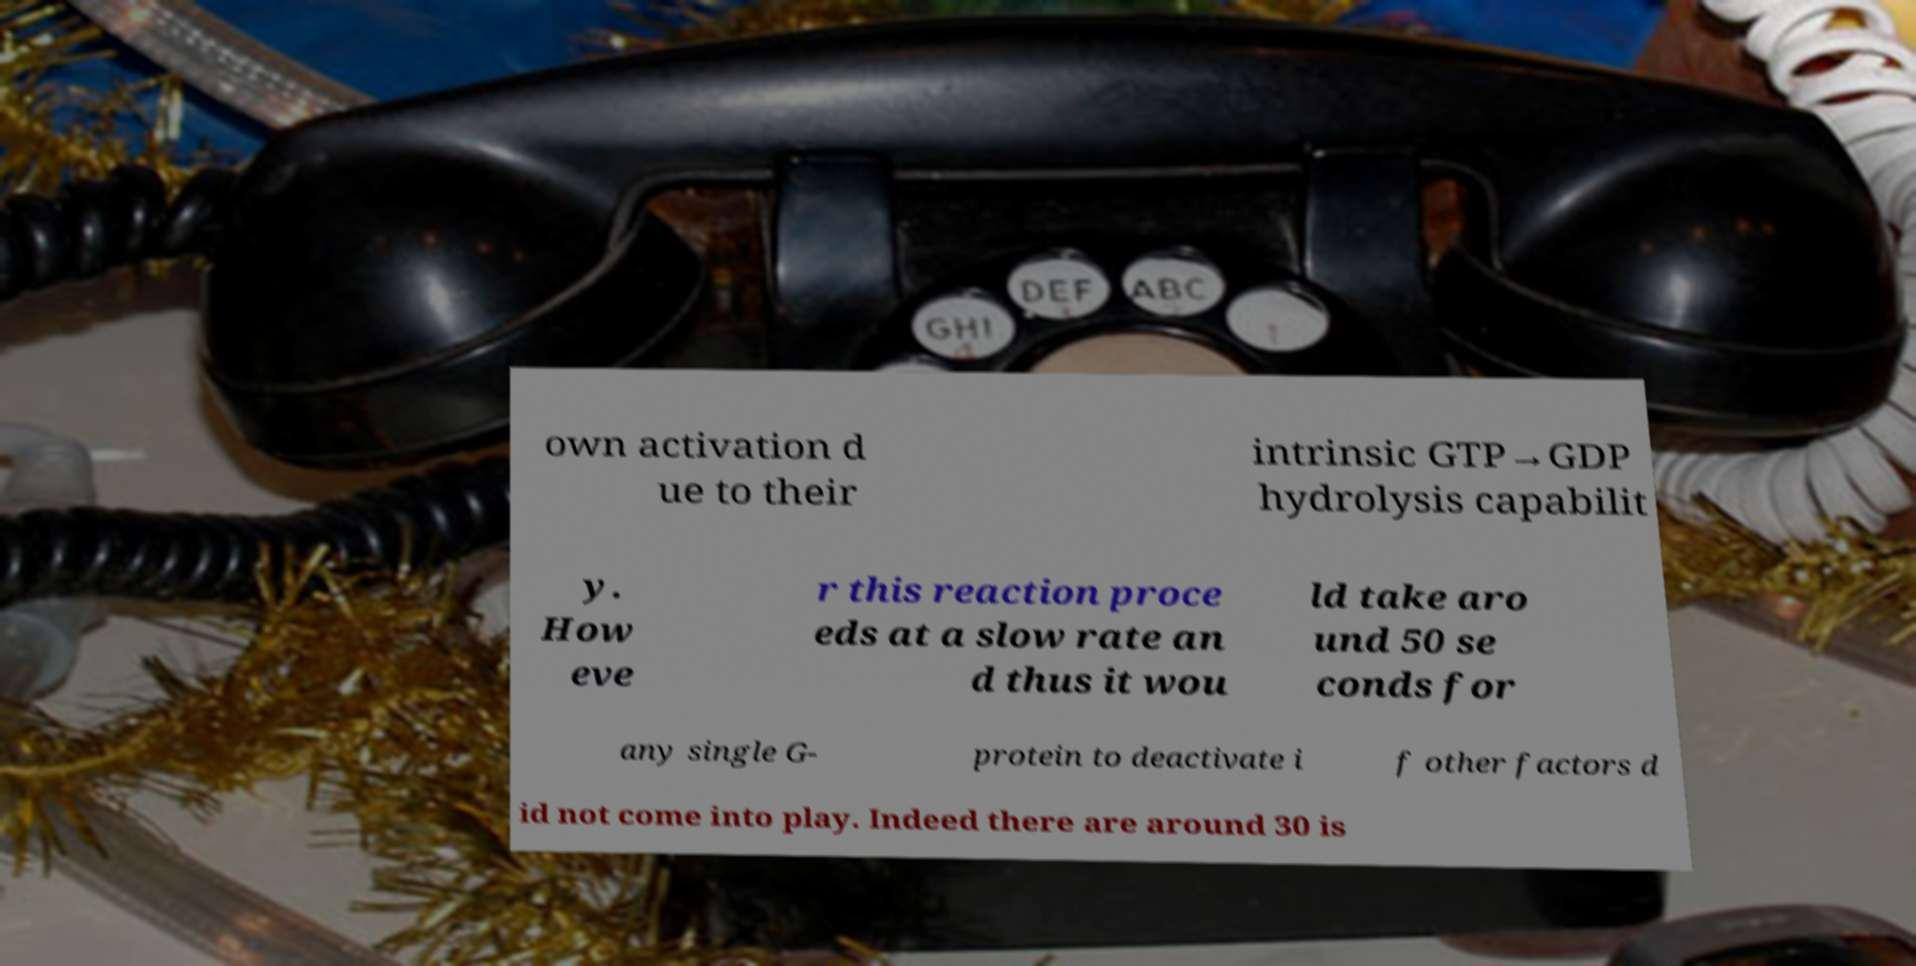I need the written content from this picture converted into text. Can you do that? own activation d ue to their intrinsic GTP→GDP hydrolysis capabilit y. How eve r this reaction proce eds at a slow rate an d thus it wou ld take aro und 50 se conds for any single G- protein to deactivate i f other factors d id not come into play. Indeed there are around 30 is 